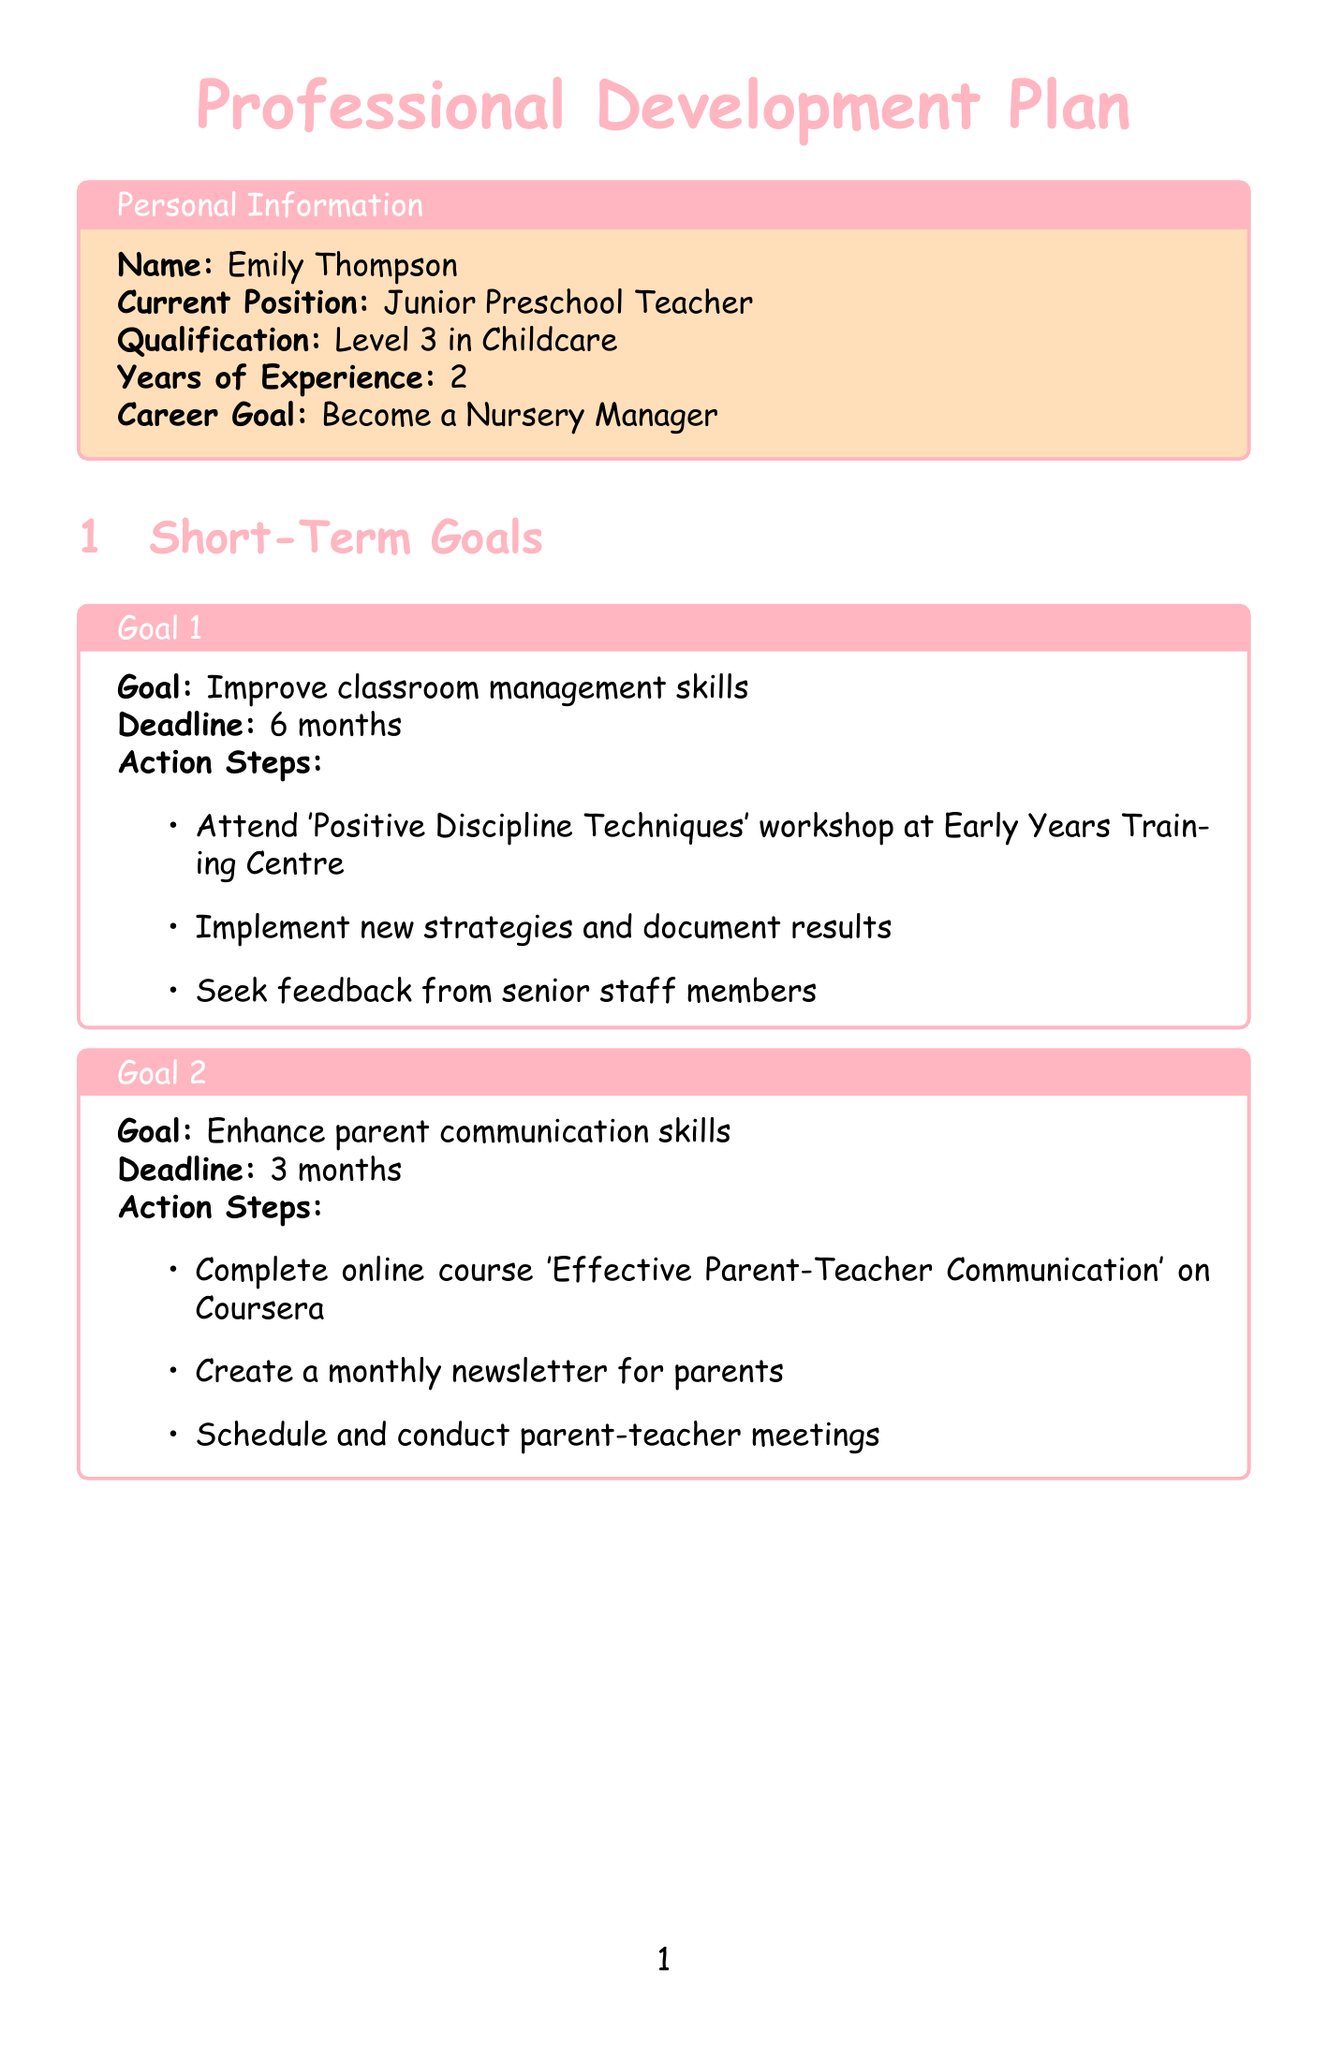What is the name of the individual? The name mentioned in the document is Emily Thompson.
Answer: Emily Thompson What is Emily's current position? The document explicitly states her current position as Junior Preschool Teacher.
Answer: Junior Preschool Teacher How long does Emily have to improve her classroom management skills? The deadline for this goal is specified as 6 months.
Answer: 6 months What is one of the training opportunities listed? The document includes several training opportunities, one of which is Paediatric First Aid.
Answer: Paediatric First Aid What is the target level for Emily's leadership skills? The document outlines her target level for leadership skills as Advanced.
Answer: Advanced When is the next progress review date? The document states that the next review date is August 31, 2023.
Answer: August 31, 2023 Who is Emily's current mentor? The document lists Sarah Johnson as Emily's current mentor.
Answer: Sarah Johnson What is the cost of the Safeguarding Children training? The cost mentioned for this training is £95.
Answer: £95 How often does Emily plan to meet with her mentor? The document specifies that the meeting frequency is bi-weekly.
Answer: Bi-weekly 